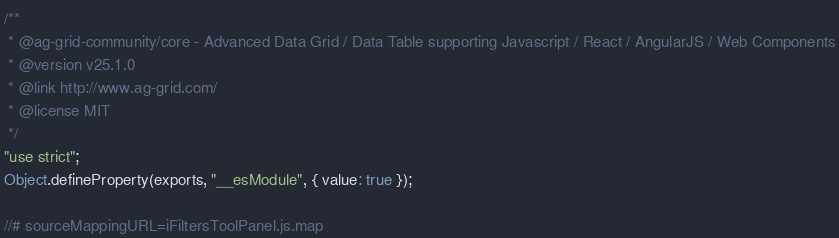Convert code to text. <code><loc_0><loc_0><loc_500><loc_500><_JavaScript_>/**
 * @ag-grid-community/core - Advanced Data Grid / Data Table supporting Javascript / React / AngularJS / Web Components
 * @version v25.1.0
 * @link http://www.ag-grid.com/
 * @license MIT
 */
"use strict";
Object.defineProperty(exports, "__esModule", { value: true });

//# sourceMappingURL=iFiltersToolPanel.js.map
</code> 